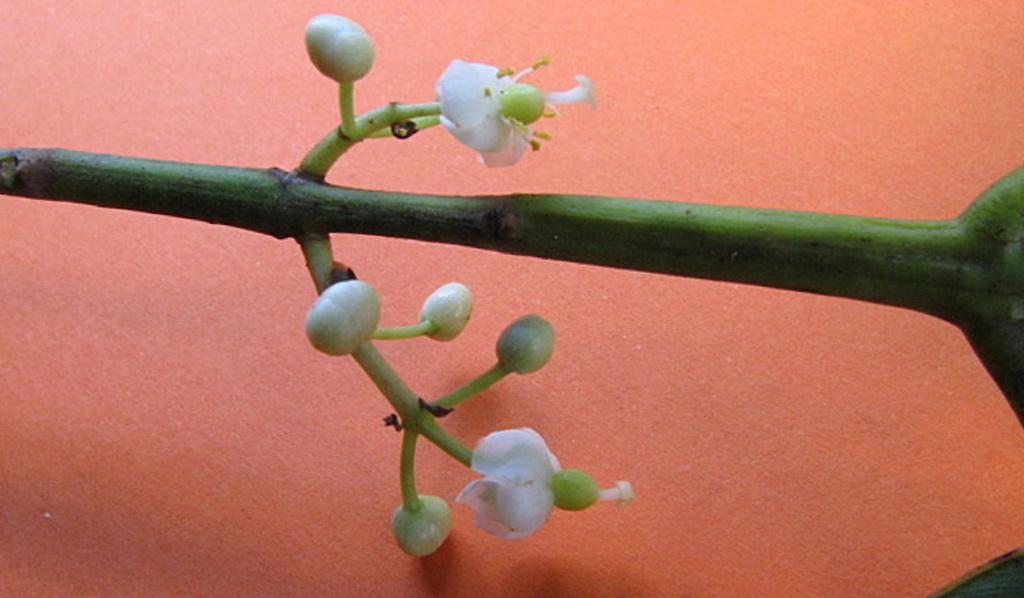What type of plant parts can be seen in the image? There are stems, buds, and flowers in the image. Can you describe the stage of growth for the plants in the image? The presence of buds and flowers suggests that the plants are in the blooming stage. What is visible in the background of the image? There is a wall in the background of the image. What type of pet can be seen interacting with the flowers in the image? There is no pet present in the image; it only features plants and a wall in the background. 